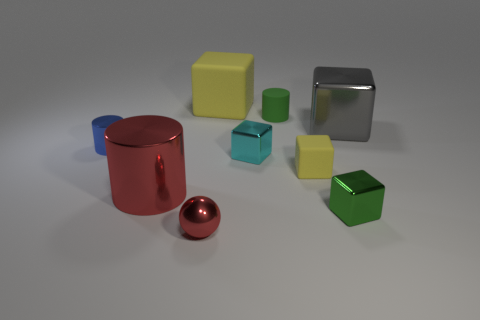What is the color of the cylinder that is made of the same material as the big yellow cube? The cylinder sharing the same material characteristics as the big yellow cube has a reflective metallic surface, and its color is red. 